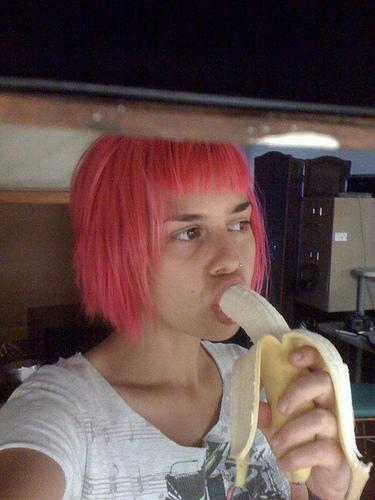Question: what food is shown?
Choices:
A. An apple.
B. A banana.
C. A peach.
D. An orange.
Answer with the letter. Answer: B Question: what color is the woman's hair?
Choices:
A. Pink.
B. Brown.
C. Red.
D. Grey.
Answer with the letter. Answer: A Question: how many bananas does she have?
Choices:
A. Two.
B. One.
C. Five.
D. Six.
Answer with the letter. Answer: B Question: why is she eating a banana?
Choices:
A. It is the only food that is available.
B. She is hungry.
C. She is a monkey.
D. It is a contest.
Answer with the letter. Answer: B Question: who is eating a banana?
Choices:
A. The woman.
B. The monkey.
C. The elephant.
D. The baby.
Answer with the letter. Answer: A Question: where is the banana?
Choices:
A. In the store.
B. In her mouth.
C. On the counter.
D. In the garbage.
Answer with the letter. Answer: B Question: when was the photo taken?
Choices:
A. During a lunar eclipse.
B. Daytime.
C. During a robbery.
D. In the winter.
Answer with the letter. Answer: B 